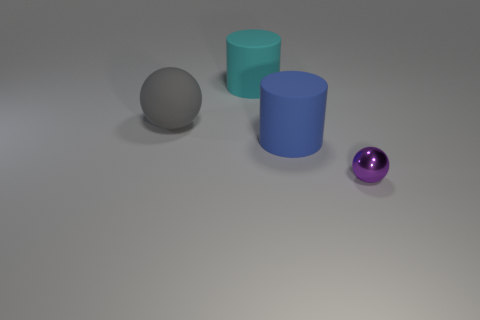There is a thing behind the large gray thing; is it the same size as the ball that is on the right side of the gray rubber ball?
Give a very brief answer. No. Are there any objects left of the small purple thing?
Offer a terse response. Yes. Do the big thing that is behind the gray thing and the rubber thing that is to the right of the big cyan cylinder have the same shape?
Your answer should be compact. Yes. How many objects are large red matte spheres or objects in front of the big matte ball?
Provide a succinct answer. 2. What number of other objects are there of the same shape as the big blue object?
Give a very brief answer. 1. Does the large thing that is in front of the matte sphere have the same material as the gray thing?
Your response must be concise. Yes. How many objects are blue objects or metal spheres?
Give a very brief answer. 2. What size is the purple object that is the same shape as the big gray rubber object?
Make the answer very short. Small. The purple thing is what size?
Give a very brief answer. Small. Are there more matte cylinders right of the gray sphere than small purple metallic things?
Your answer should be very brief. Yes. 